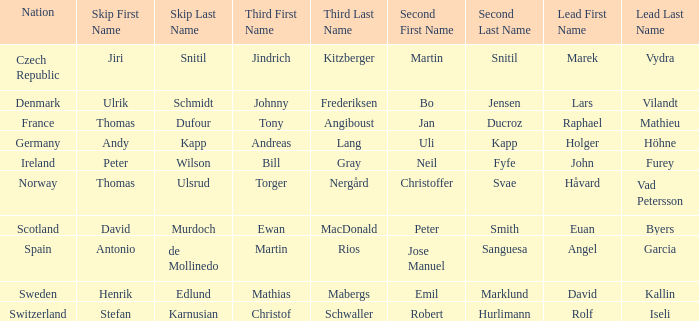In which third did angel garcia lead? Martin Rios. Can you give me this table as a dict? {'header': ['Nation', 'Skip First Name', 'Skip Last Name', 'Third First Name', 'Third Last Name', 'Second First Name', 'Second Last Name', 'Lead First Name', 'Lead Last Name'], 'rows': [['Czech Republic', 'Jiri', 'Snitil', 'Jindrich', 'Kitzberger', 'Martin', 'Snitil', 'Marek', 'Vydra'], ['Denmark', 'Ulrik', 'Schmidt', 'Johnny', 'Frederiksen', 'Bo', 'Jensen', 'Lars', 'Vilandt'], ['France', 'Thomas', 'Dufour', 'Tony', 'Angiboust', 'Jan', 'Ducroz', 'Raphael', 'Mathieu'], ['Germany', 'Andy', 'Kapp', 'Andreas', 'Lang', 'Uli', 'Kapp', 'Holger', 'Höhne'], ['Ireland', 'Peter', 'Wilson', 'Bill', 'Gray', 'Neil', 'Fyfe', 'John', 'Furey'], ['Norway', 'Thomas', 'Ulsrud', 'Torger', 'Nergård', 'Christoffer', 'Svae', 'Håvard', 'Vad Petersson'], ['Scotland', 'David', 'Murdoch', 'Ewan', 'MacDonald', 'Peter', 'Smith', 'Euan', 'Byers'], ['Spain', 'Antonio', 'de Mollinedo', 'Martin', 'Rios', 'Jose Manuel', 'Sanguesa', 'Angel', 'Garcia'], ['Sweden', 'Henrik', 'Edlund', 'Mathias', 'Mabergs', 'Emil', 'Marklund', 'David', 'Kallin'], ['Switzerland', 'Stefan', 'Karnusian', 'Christof', 'Schwaller', 'Robert', 'Hurlimann', 'Rolf', 'Iseli']]} 